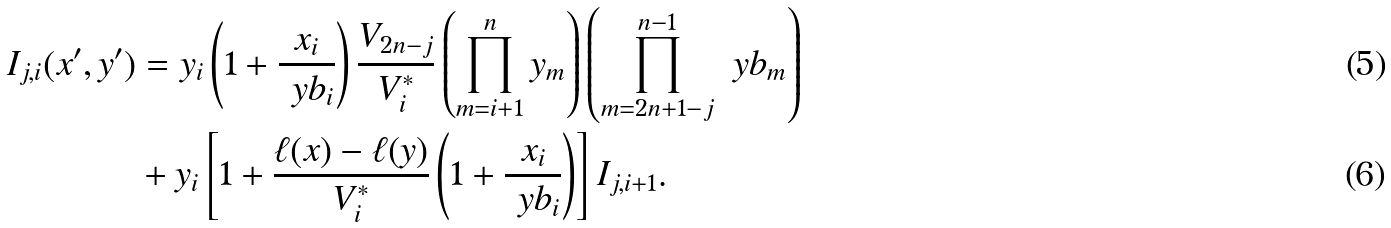<formula> <loc_0><loc_0><loc_500><loc_500>I _ { j , i } ( x ^ { \prime } , y ^ { \prime } ) & = y _ { i } \left ( 1 + \frac { x _ { i } } { \ y b _ { i } } \right ) \frac { V _ { 2 n - j } } { V _ { i } ^ { * } } \left ( \prod _ { m = i + 1 } ^ { n } y _ { m } \right ) \left ( \prod _ { m = 2 n + 1 - j } ^ { n - 1 } \ y b _ { m } \right ) \\ & + y _ { i } \left [ 1 + \frac { \ell ( x ) - \ell ( y ) } { V _ { i } ^ { * } } \left ( 1 + \frac { x _ { i } } { \ y b _ { i } } \right ) \right ] I _ { j , i + 1 } .</formula> 